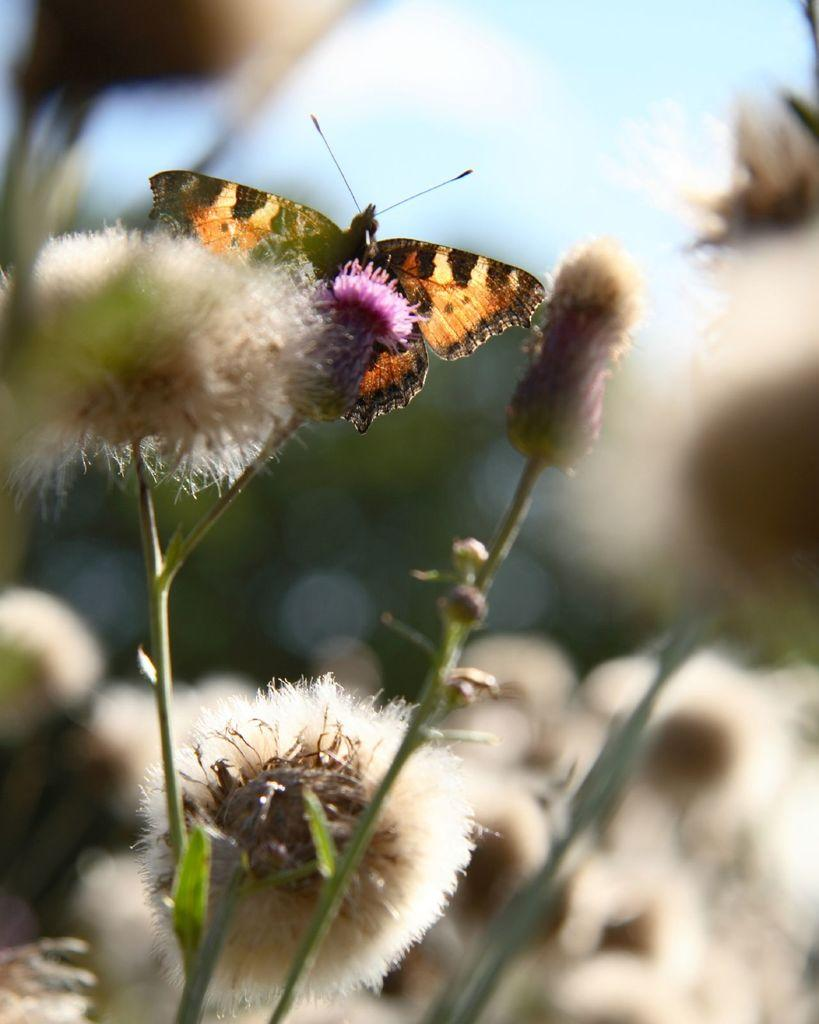What type of animal can be seen in the image? There is a butterfly in the image. What type of plants are present in the image? There are flower plants in the image. What type of trousers is the butterfly wearing in the image? Butterflies do not wear trousers, as they are insects and do not have clothing. Can you tell me how many berries are on the flower plants in the image? There is no mention of berries in the image; it only features a butterfly and flower plants. 